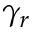<formula> <loc_0><loc_0><loc_500><loc_500>\gamma _ { r }</formula> 